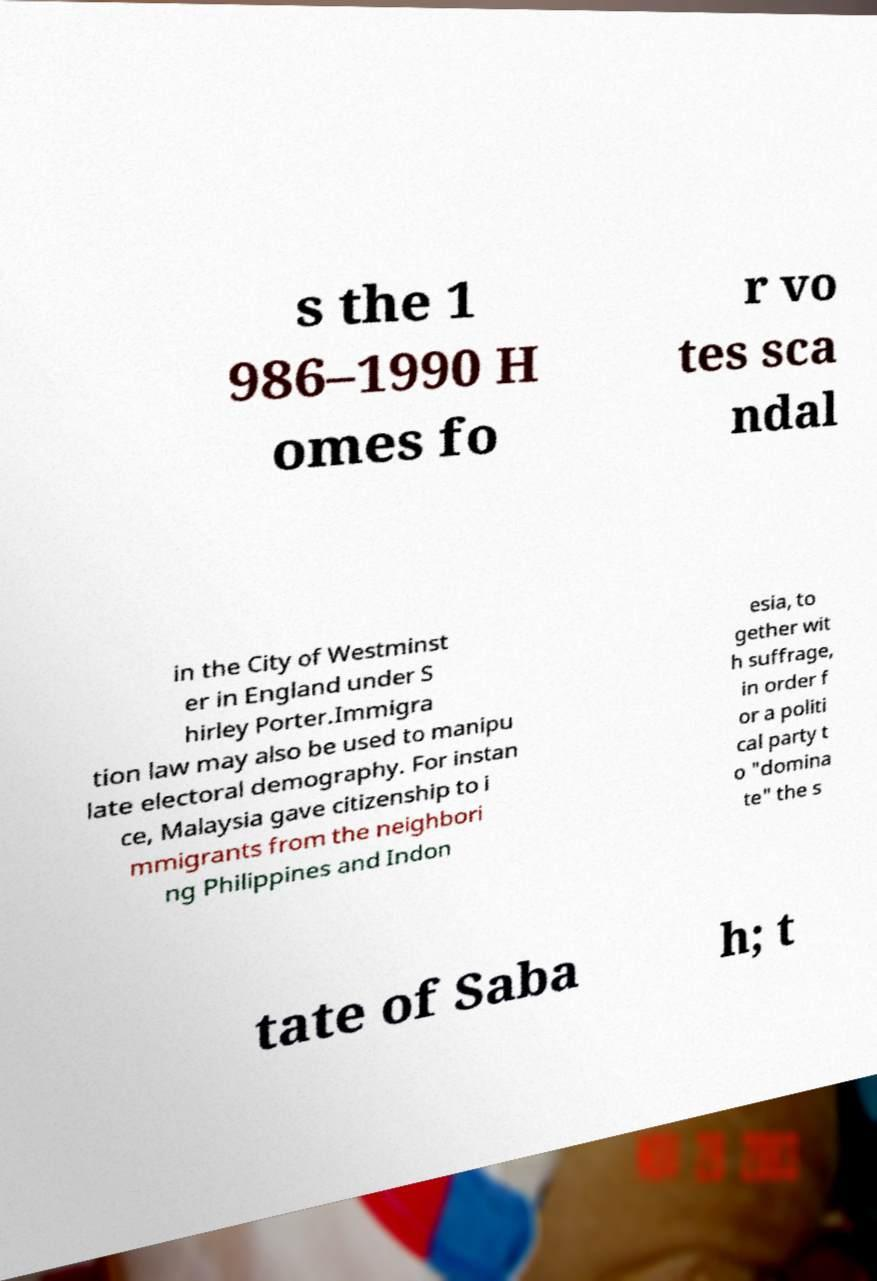What messages or text are displayed in this image? I need them in a readable, typed format. s the 1 986–1990 H omes fo r vo tes sca ndal in the City of Westminst er in England under S hirley Porter.Immigra tion law may also be used to manipu late electoral demography. For instan ce, Malaysia gave citizenship to i mmigrants from the neighbori ng Philippines and Indon esia, to gether wit h suffrage, in order f or a politi cal party t o "domina te" the s tate of Saba h; t 